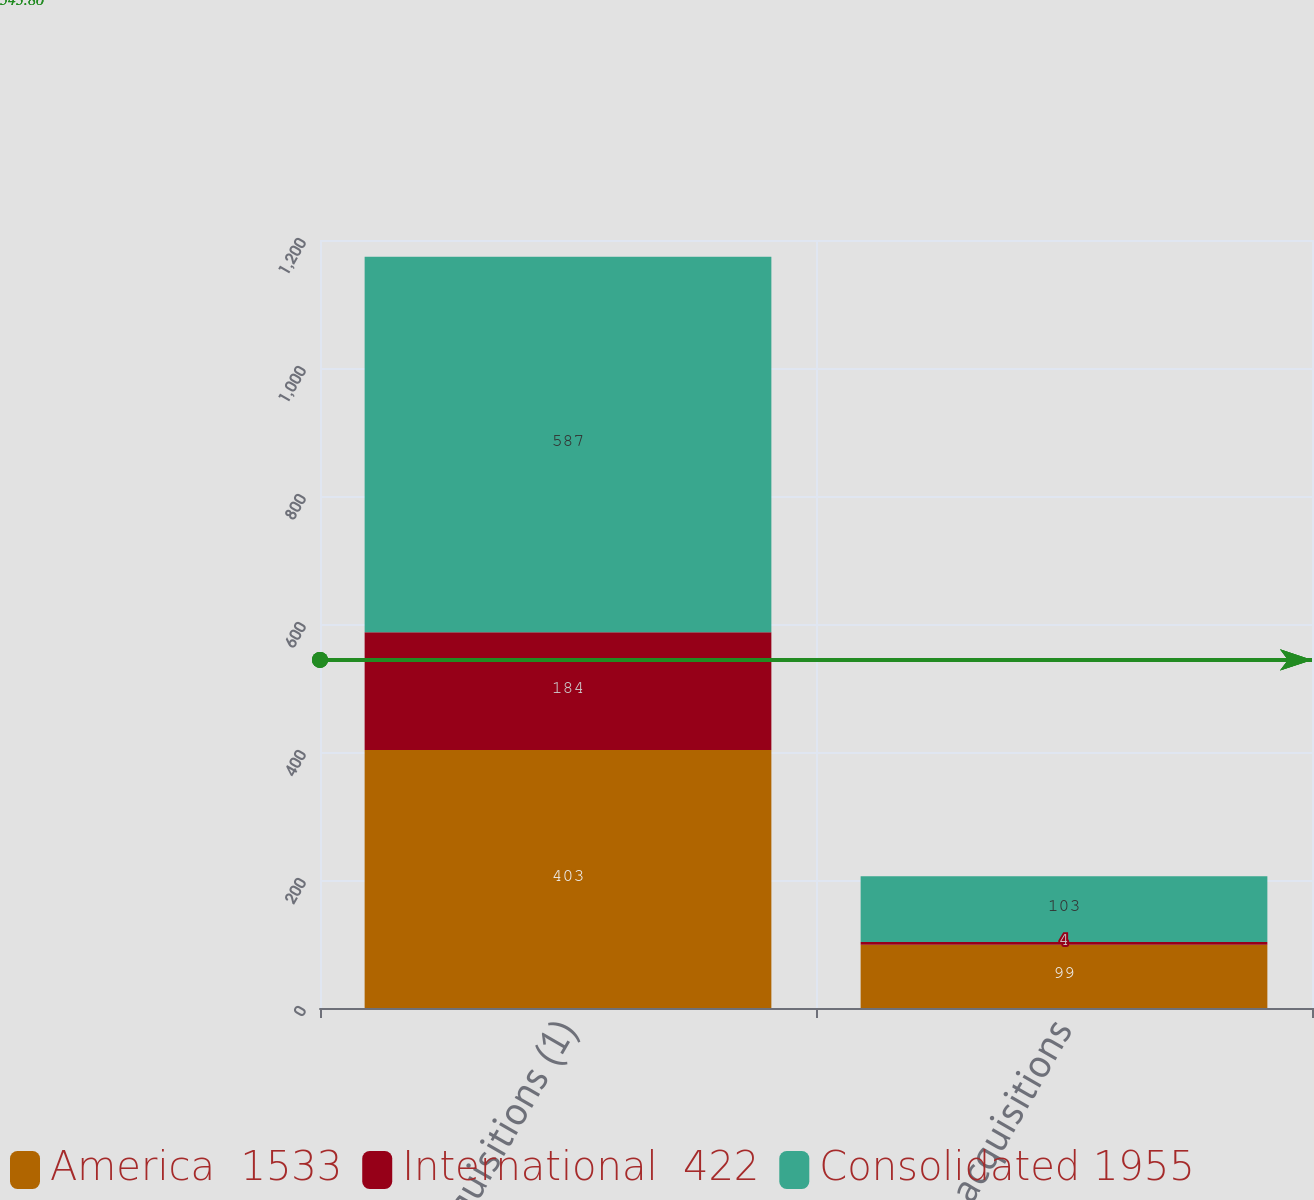Convert chart to OTSL. <chart><loc_0><loc_0><loc_500><loc_500><stacked_bar_chart><ecel><fcel>New acquisitions (1)<fcel>New acquisitions<nl><fcel>America  1533<fcel>403<fcel>99<nl><fcel>International  422<fcel>184<fcel>4<nl><fcel>Consolidated 1955<fcel>587<fcel>103<nl></chart> 